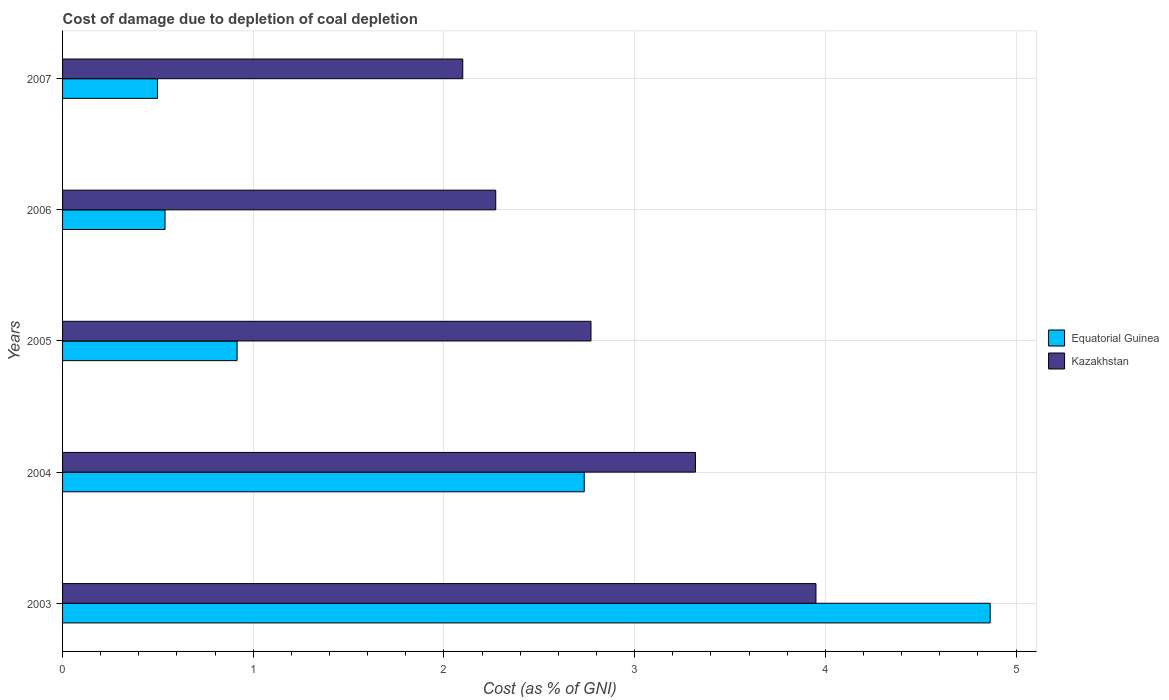How many different coloured bars are there?
Provide a short and direct response. 2. How many groups of bars are there?
Your answer should be compact. 5. Are the number of bars per tick equal to the number of legend labels?
Keep it short and to the point. Yes. Are the number of bars on each tick of the Y-axis equal?
Offer a terse response. Yes. How many bars are there on the 2nd tick from the top?
Provide a succinct answer. 2. What is the cost of damage caused due to coal depletion in Equatorial Guinea in 2007?
Give a very brief answer. 0.5. Across all years, what is the maximum cost of damage caused due to coal depletion in Equatorial Guinea?
Offer a very short reply. 4.86. Across all years, what is the minimum cost of damage caused due to coal depletion in Kazakhstan?
Offer a very short reply. 2.1. What is the total cost of damage caused due to coal depletion in Equatorial Guinea in the graph?
Give a very brief answer. 9.55. What is the difference between the cost of damage caused due to coal depletion in Equatorial Guinea in 2006 and that in 2007?
Your answer should be compact. 0.04. What is the difference between the cost of damage caused due to coal depletion in Equatorial Guinea in 2006 and the cost of damage caused due to coal depletion in Kazakhstan in 2003?
Provide a short and direct response. -3.41. What is the average cost of damage caused due to coal depletion in Equatorial Guinea per year?
Provide a short and direct response. 1.91. In the year 2004, what is the difference between the cost of damage caused due to coal depletion in Kazakhstan and cost of damage caused due to coal depletion in Equatorial Guinea?
Keep it short and to the point. 0.58. In how many years, is the cost of damage caused due to coal depletion in Kazakhstan greater than 1.4 %?
Provide a succinct answer. 5. What is the ratio of the cost of damage caused due to coal depletion in Equatorial Guinea in 2005 to that in 2007?
Your answer should be compact. 1.84. Is the cost of damage caused due to coal depletion in Equatorial Guinea in 2005 less than that in 2006?
Your answer should be very brief. No. What is the difference between the highest and the second highest cost of damage caused due to coal depletion in Equatorial Guinea?
Ensure brevity in your answer.  2.13. What is the difference between the highest and the lowest cost of damage caused due to coal depletion in Kazakhstan?
Your response must be concise. 1.85. What does the 2nd bar from the top in 2007 represents?
Your answer should be very brief. Equatorial Guinea. What does the 1st bar from the bottom in 2006 represents?
Offer a terse response. Equatorial Guinea. Are all the bars in the graph horizontal?
Offer a very short reply. Yes. Does the graph contain any zero values?
Your answer should be compact. No. Does the graph contain grids?
Offer a terse response. Yes. Where does the legend appear in the graph?
Offer a terse response. Center right. How many legend labels are there?
Ensure brevity in your answer.  2. What is the title of the graph?
Provide a succinct answer. Cost of damage due to depletion of coal depletion. What is the label or title of the X-axis?
Your answer should be very brief. Cost (as % of GNI). What is the Cost (as % of GNI) of Equatorial Guinea in 2003?
Keep it short and to the point. 4.86. What is the Cost (as % of GNI) in Kazakhstan in 2003?
Offer a terse response. 3.95. What is the Cost (as % of GNI) of Equatorial Guinea in 2004?
Offer a very short reply. 2.74. What is the Cost (as % of GNI) in Kazakhstan in 2004?
Offer a terse response. 3.32. What is the Cost (as % of GNI) of Equatorial Guinea in 2005?
Your response must be concise. 0.92. What is the Cost (as % of GNI) of Kazakhstan in 2005?
Keep it short and to the point. 2.77. What is the Cost (as % of GNI) in Equatorial Guinea in 2006?
Your response must be concise. 0.54. What is the Cost (as % of GNI) of Kazakhstan in 2006?
Offer a terse response. 2.27. What is the Cost (as % of GNI) of Equatorial Guinea in 2007?
Make the answer very short. 0.5. What is the Cost (as % of GNI) of Kazakhstan in 2007?
Make the answer very short. 2.1. Across all years, what is the maximum Cost (as % of GNI) of Equatorial Guinea?
Make the answer very short. 4.86. Across all years, what is the maximum Cost (as % of GNI) in Kazakhstan?
Provide a succinct answer. 3.95. Across all years, what is the minimum Cost (as % of GNI) of Equatorial Guinea?
Ensure brevity in your answer.  0.5. Across all years, what is the minimum Cost (as % of GNI) of Kazakhstan?
Give a very brief answer. 2.1. What is the total Cost (as % of GNI) of Equatorial Guinea in the graph?
Ensure brevity in your answer.  9.55. What is the total Cost (as % of GNI) in Kazakhstan in the graph?
Make the answer very short. 14.41. What is the difference between the Cost (as % of GNI) of Equatorial Guinea in 2003 and that in 2004?
Provide a succinct answer. 2.13. What is the difference between the Cost (as % of GNI) of Kazakhstan in 2003 and that in 2004?
Provide a short and direct response. 0.63. What is the difference between the Cost (as % of GNI) of Equatorial Guinea in 2003 and that in 2005?
Give a very brief answer. 3.95. What is the difference between the Cost (as % of GNI) in Kazakhstan in 2003 and that in 2005?
Give a very brief answer. 1.18. What is the difference between the Cost (as % of GNI) of Equatorial Guinea in 2003 and that in 2006?
Your answer should be very brief. 4.33. What is the difference between the Cost (as % of GNI) in Kazakhstan in 2003 and that in 2006?
Provide a short and direct response. 1.68. What is the difference between the Cost (as % of GNI) of Equatorial Guinea in 2003 and that in 2007?
Provide a succinct answer. 4.37. What is the difference between the Cost (as % of GNI) of Kazakhstan in 2003 and that in 2007?
Offer a terse response. 1.85. What is the difference between the Cost (as % of GNI) in Equatorial Guinea in 2004 and that in 2005?
Offer a very short reply. 1.82. What is the difference between the Cost (as % of GNI) of Kazakhstan in 2004 and that in 2005?
Ensure brevity in your answer.  0.55. What is the difference between the Cost (as % of GNI) of Equatorial Guinea in 2004 and that in 2006?
Your answer should be very brief. 2.2. What is the difference between the Cost (as % of GNI) in Kazakhstan in 2004 and that in 2006?
Offer a very short reply. 1.05. What is the difference between the Cost (as % of GNI) in Equatorial Guinea in 2004 and that in 2007?
Give a very brief answer. 2.24. What is the difference between the Cost (as % of GNI) in Kazakhstan in 2004 and that in 2007?
Keep it short and to the point. 1.22. What is the difference between the Cost (as % of GNI) in Equatorial Guinea in 2005 and that in 2006?
Offer a terse response. 0.38. What is the difference between the Cost (as % of GNI) of Kazakhstan in 2005 and that in 2006?
Offer a terse response. 0.5. What is the difference between the Cost (as % of GNI) in Equatorial Guinea in 2005 and that in 2007?
Offer a terse response. 0.42. What is the difference between the Cost (as % of GNI) of Kazakhstan in 2005 and that in 2007?
Your answer should be compact. 0.67. What is the difference between the Cost (as % of GNI) in Equatorial Guinea in 2006 and that in 2007?
Your response must be concise. 0.04. What is the difference between the Cost (as % of GNI) in Kazakhstan in 2006 and that in 2007?
Offer a terse response. 0.17. What is the difference between the Cost (as % of GNI) of Equatorial Guinea in 2003 and the Cost (as % of GNI) of Kazakhstan in 2004?
Your response must be concise. 1.55. What is the difference between the Cost (as % of GNI) of Equatorial Guinea in 2003 and the Cost (as % of GNI) of Kazakhstan in 2005?
Your answer should be compact. 2.09. What is the difference between the Cost (as % of GNI) of Equatorial Guinea in 2003 and the Cost (as % of GNI) of Kazakhstan in 2006?
Your response must be concise. 2.59. What is the difference between the Cost (as % of GNI) of Equatorial Guinea in 2003 and the Cost (as % of GNI) of Kazakhstan in 2007?
Your response must be concise. 2.77. What is the difference between the Cost (as % of GNI) in Equatorial Guinea in 2004 and the Cost (as % of GNI) in Kazakhstan in 2005?
Offer a very short reply. -0.04. What is the difference between the Cost (as % of GNI) of Equatorial Guinea in 2004 and the Cost (as % of GNI) of Kazakhstan in 2006?
Offer a terse response. 0.46. What is the difference between the Cost (as % of GNI) of Equatorial Guinea in 2004 and the Cost (as % of GNI) of Kazakhstan in 2007?
Offer a terse response. 0.64. What is the difference between the Cost (as % of GNI) of Equatorial Guinea in 2005 and the Cost (as % of GNI) of Kazakhstan in 2006?
Your answer should be compact. -1.36. What is the difference between the Cost (as % of GNI) of Equatorial Guinea in 2005 and the Cost (as % of GNI) of Kazakhstan in 2007?
Provide a short and direct response. -1.18. What is the difference between the Cost (as % of GNI) in Equatorial Guinea in 2006 and the Cost (as % of GNI) in Kazakhstan in 2007?
Provide a succinct answer. -1.56. What is the average Cost (as % of GNI) in Equatorial Guinea per year?
Make the answer very short. 1.91. What is the average Cost (as % of GNI) in Kazakhstan per year?
Provide a succinct answer. 2.88. In the year 2003, what is the difference between the Cost (as % of GNI) in Equatorial Guinea and Cost (as % of GNI) in Kazakhstan?
Your answer should be very brief. 0.91. In the year 2004, what is the difference between the Cost (as % of GNI) of Equatorial Guinea and Cost (as % of GNI) of Kazakhstan?
Make the answer very short. -0.58. In the year 2005, what is the difference between the Cost (as % of GNI) in Equatorial Guinea and Cost (as % of GNI) in Kazakhstan?
Give a very brief answer. -1.86. In the year 2006, what is the difference between the Cost (as % of GNI) in Equatorial Guinea and Cost (as % of GNI) in Kazakhstan?
Offer a terse response. -1.73. In the year 2007, what is the difference between the Cost (as % of GNI) in Equatorial Guinea and Cost (as % of GNI) in Kazakhstan?
Your answer should be very brief. -1.6. What is the ratio of the Cost (as % of GNI) of Equatorial Guinea in 2003 to that in 2004?
Your answer should be compact. 1.78. What is the ratio of the Cost (as % of GNI) in Kazakhstan in 2003 to that in 2004?
Offer a terse response. 1.19. What is the ratio of the Cost (as % of GNI) of Equatorial Guinea in 2003 to that in 2005?
Offer a very short reply. 5.32. What is the ratio of the Cost (as % of GNI) of Kazakhstan in 2003 to that in 2005?
Ensure brevity in your answer.  1.43. What is the ratio of the Cost (as % of GNI) in Equatorial Guinea in 2003 to that in 2006?
Your response must be concise. 9.05. What is the ratio of the Cost (as % of GNI) of Kazakhstan in 2003 to that in 2006?
Your answer should be compact. 1.74. What is the ratio of the Cost (as % of GNI) in Equatorial Guinea in 2003 to that in 2007?
Make the answer very short. 9.77. What is the ratio of the Cost (as % of GNI) in Kazakhstan in 2003 to that in 2007?
Make the answer very short. 1.88. What is the ratio of the Cost (as % of GNI) in Equatorial Guinea in 2004 to that in 2005?
Your answer should be compact. 2.99. What is the ratio of the Cost (as % of GNI) of Kazakhstan in 2004 to that in 2005?
Ensure brevity in your answer.  1.2. What is the ratio of the Cost (as % of GNI) in Equatorial Guinea in 2004 to that in 2006?
Your response must be concise. 5.09. What is the ratio of the Cost (as % of GNI) of Kazakhstan in 2004 to that in 2006?
Keep it short and to the point. 1.46. What is the ratio of the Cost (as % of GNI) of Equatorial Guinea in 2004 to that in 2007?
Keep it short and to the point. 5.49. What is the ratio of the Cost (as % of GNI) of Kazakhstan in 2004 to that in 2007?
Provide a short and direct response. 1.58. What is the ratio of the Cost (as % of GNI) in Equatorial Guinea in 2005 to that in 2006?
Give a very brief answer. 1.7. What is the ratio of the Cost (as % of GNI) in Kazakhstan in 2005 to that in 2006?
Your answer should be very brief. 1.22. What is the ratio of the Cost (as % of GNI) of Equatorial Guinea in 2005 to that in 2007?
Give a very brief answer. 1.84. What is the ratio of the Cost (as % of GNI) of Kazakhstan in 2005 to that in 2007?
Ensure brevity in your answer.  1.32. What is the ratio of the Cost (as % of GNI) in Equatorial Guinea in 2006 to that in 2007?
Offer a very short reply. 1.08. What is the ratio of the Cost (as % of GNI) of Kazakhstan in 2006 to that in 2007?
Offer a very short reply. 1.08. What is the difference between the highest and the second highest Cost (as % of GNI) of Equatorial Guinea?
Keep it short and to the point. 2.13. What is the difference between the highest and the second highest Cost (as % of GNI) of Kazakhstan?
Your answer should be very brief. 0.63. What is the difference between the highest and the lowest Cost (as % of GNI) in Equatorial Guinea?
Offer a very short reply. 4.37. What is the difference between the highest and the lowest Cost (as % of GNI) in Kazakhstan?
Make the answer very short. 1.85. 